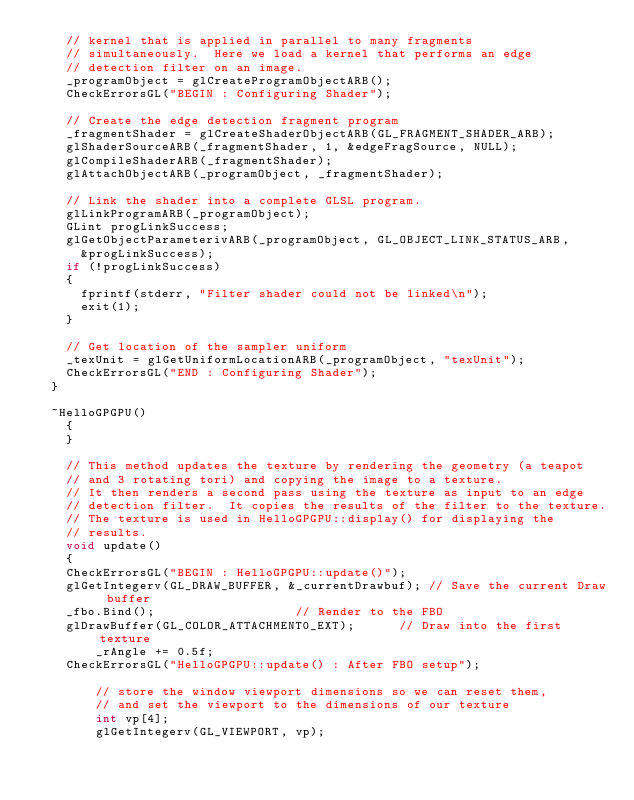Convert code to text. <code><loc_0><loc_0><loc_500><loc_500><_C++_>		// kernel that is applied in parallel to many fragments
		// simultaneously.  Here we load a kernel that performs an edge
		// detection filter on an image.
		_programObject = glCreateProgramObjectARB();
		CheckErrorsGL("BEGIN : Configuring Shader");

		// Create the edge detection fragment program
		_fragmentShader = glCreateShaderObjectARB(GL_FRAGMENT_SHADER_ARB);
		glShaderSourceARB(_fragmentShader, 1, &edgeFragSource, NULL);
		glCompileShaderARB(_fragmentShader);
		glAttachObjectARB(_programObject, _fragmentShader);

		// Link the shader into a complete GLSL program.
		glLinkProgramARB(_programObject);
		GLint progLinkSuccess;
		glGetObjectParameterivARB(_programObject, GL_OBJECT_LINK_STATUS_ARB,
			&progLinkSuccess);
		if (!progLinkSuccess)
		{
			fprintf(stderr, "Filter shader could not be linked\n");
			exit(1);
		}

		// Get location of the sampler uniform
		_texUnit = glGetUniformLocationARB(_programObject, "texUnit");
		CheckErrorsGL("END : Configuring Shader");
	}

	~HelloGPGPU()
    {
    }

    // This method updates the texture by rendering the geometry (a teapot
    // and 3 rotating tori) and copying the image to a texture.
    // It then renders a second pass using the texture as input to an edge
    // detection filter.  It copies the results of the filter to the texture.
    // The texture is used in HelloGPGPU::display() for displaying the
    // results.
    void update()
    {
		CheckErrorsGL("BEGIN : HelloGPGPU::update()");
		glGetIntegerv(GL_DRAW_BUFFER, &_currentDrawbuf); // Save the current Draw buffer
		_fbo.Bind(); 									 // Render to the FBO
		glDrawBuffer(GL_COLOR_ATTACHMENT0_EXT);			 // Draw into the first texture
        _rAngle += 0.5f;
		CheckErrorsGL("HelloGPGPU::update() : After FBO setup");

        // store the window viewport dimensions so we can reset them,
        // and set the viewport to the dimensions of our texture
        int vp[4];
        glGetIntegerv(GL_VIEWPORT, vp);
</code> 